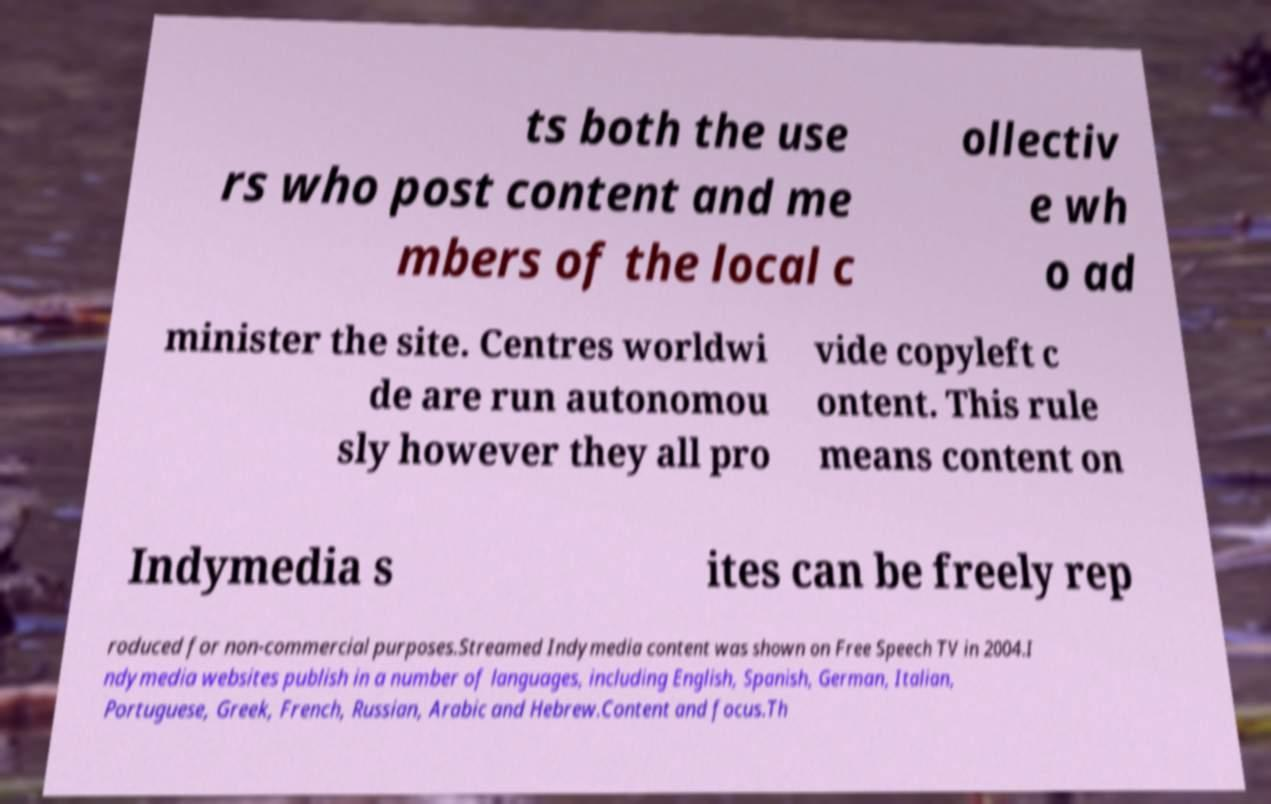I need the written content from this picture converted into text. Can you do that? ts both the use rs who post content and me mbers of the local c ollectiv e wh o ad minister the site. Centres worldwi de are run autonomou sly however they all pro vide copyleft c ontent. This rule means content on Indymedia s ites can be freely rep roduced for non-commercial purposes.Streamed Indymedia content was shown on Free Speech TV in 2004.I ndymedia websites publish in a number of languages, including English, Spanish, German, Italian, Portuguese, Greek, French, Russian, Arabic and Hebrew.Content and focus.Th 